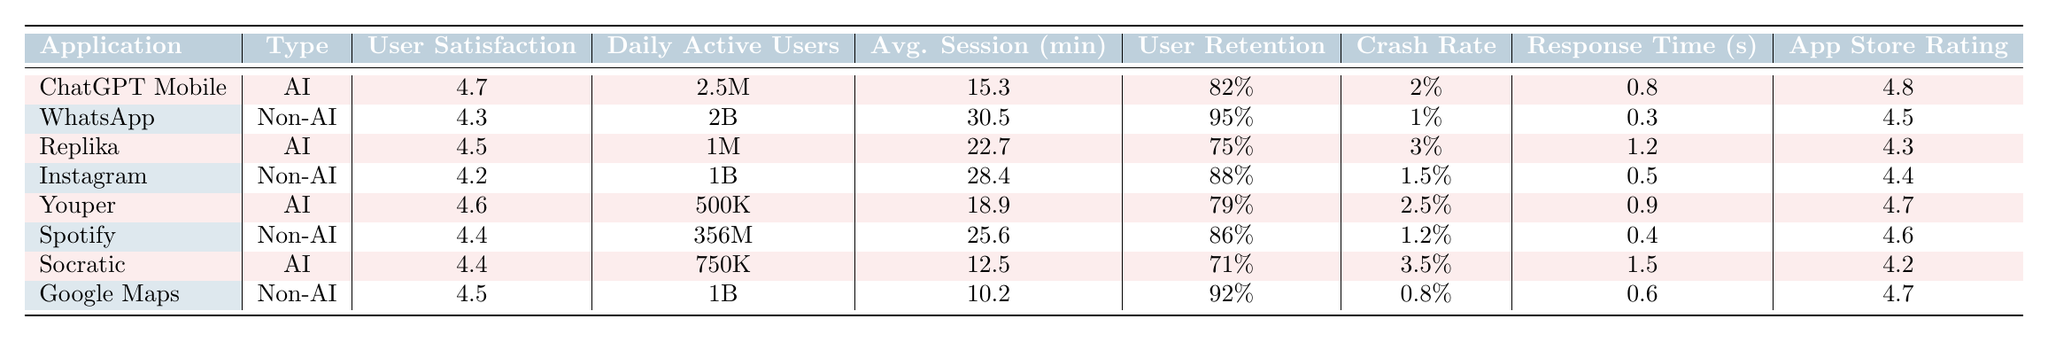What is the user satisfaction rating for ChatGPT Mobile? The user satisfaction rating for ChatGPT Mobile is explicitly listed in the table under the "User Satisfaction" column. It shows a value of 4.7.
Answer: 4.7 How many daily active users does WhatsApp have? The table states that WhatsApp has 2 billion (2B) daily active users, which is listed in the "Daily Active Users" column.
Answer: 2 billion Which AI-powered application has the lowest user retention rate? By looking at the "User Retention" column, we can see that Socratic has a user retention rate of 71%, which is lower than the other AI applications: ChatGPT Mobile (82%), Replika (75%), and Youper (79%).
Answer: Socratic What is the average session duration for Instagram? The table shows that the average session duration for Instagram is 28.4 minutes, which can be found under the "Avg. Session (min)" column.
Answer: 28.4 minutes Is the crash rate for Google Maps lower than that for Replika? The crash rate for Google Maps is listed as 0.8%, while Replika's crash rate is 3%. Since 0.8% is less than 3%, the answer is yes.
Answer: Yes Which application has the highest app store rating? To determine which application has the highest app store rating, we compare the values in the "App Store Rating" column. ChatGPT Mobile has 4.8, which is the highest among all the listed applications.
Answer: ChatGPT Mobile What is the difference in daily active users between Spotify and Youper? Spotify has 356 million (356M) daily active users and Youper has 500,000 (500K). Converting 356M to thousands gives 356,000. The difference is: 356,000 - 500 = 355,500.
Answer: 355,500 users Which AI application has the shortest average session duration? Looking at the "Avg. Session (min)" column, Socratic has an average session duration of 12.5 minutes, which is shorter than the other AI applications: ChatGPT Mobile (15.3), Replika (22.7), and Youper (18.9).
Answer: Socratic Do any of the AI-powered applications have a user satisfaction rating below 4.5? Checking the "User Satisfaction" column, Replika has a rating of 4.5, and Socratic has 4.4, which is the only one below 4.5. So, the answer is yes.
Answer: Yes What is the average user retention rate of Non-AI applications? The non-AI applications are WhatsApp (95%), Instagram (88%), Spotify (86%), and Google Maps (92%). Adding these rates gives 361%. Dividing by 4 provides an average of 90.25%.
Answer: 90.25% 